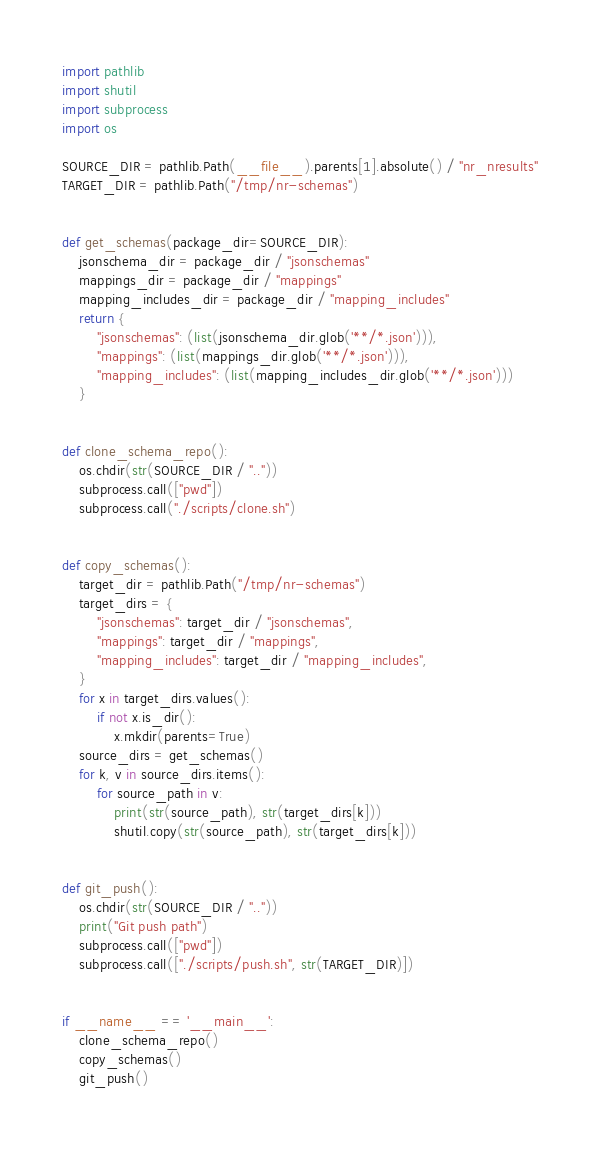<code> <loc_0><loc_0><loc_500><loc_500><_Python_>import pathlib
import shutil
import subprocess
import os

SOURCE_DIR = pathlib.Path(__file__).parents[1].absolute() / "nr_nresults"
TARGET_DIR = pathlib.Path("/tmp/nr-schemas")


def get_schemas(package_dir=SOURCE_DIR):
    jsonschema_dir = package_dir / "jsonschemas"
    mappings_dir = package_dir / "mappings"
    mapping_includes_dir = package_dir / "mapping_includes"
    return {
        "jsonschemas": (list(jsonschema_dir.glob('**/*.json'))),
        "mappings": (list(mappings_dir.glob('**/*.json'))),
        "mapping_includes": (list(mapping_includes_dir.glob('**/*.json')))
    }


def clone_schema_repo():
    os.chdir(str(SOURCE_DIR / ".."))
    subprocess.call(["pwd"])
    subprocess.call("./scripts/clone.sh")


def copy_schemas():
    target_dir = pathlib.Path("/tmp/nr-schemas")
    target_dirs = {
        "jsonschemas": target_dir / "jsonschemas",
        "mappings": target_dir / "mappings",
        "mapping_includes": target_dir / "mapping_includes",
    }
    for x in target_dirs.values():
        if not x.is_dir():
            x.mkdir(parents=True)
    source_dirs = get_schemas()
    for k, v in source_dirs.items():
        for source_path in v:
            print(str(source_path), str(target_dirs[k]))
            shutil.copy(str(source_path), str(target_dirs[k]))


def git_push():
    os.chdir(str(SOURCE_DIR / ".."))
    print("Git push path")
    subprocess.call(["pwd"])
    subprocess.call(["./scripts/push.sh", str(TARGET_DIR)])


if __name__ == '__main__':
    clone_schema_repo()
    copy_schemas()
    git_push()
</code> 